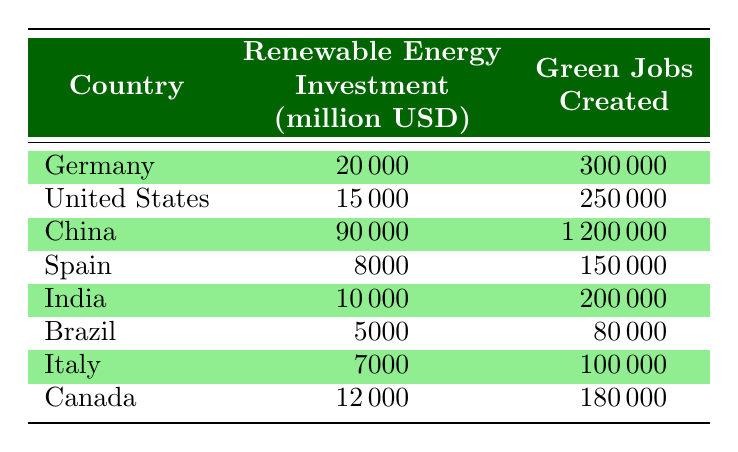What is the renewable energy investment in China? The table lists China’s renewable energy investment, which is specifically provided in the row corresponding to China. It shows a value of 90000 million USD.
Answer: 90000 million USD Which country created the most green jobs? By examining the green jobs created across all countries listed in the table, China has the highest number at 1200000.
Answer: China What is the total renewable energy investment for Germany and Canada combined? To find the total, add Germany's investment of 20000 million USD and Canada's investment of 12000 million USD together: 20000 + 12000 = 32000 million USD.
Answer: 32000 million USD Is it true that Spain created more green jobs than Brazil? Comparing the values from the table, Spain created 150000 green jobs while Brazil created 80000, so Spain indeed created more.
Answer: Yes What is the average number of green jobs created among all countries in the table? First, sum the green jobs created by each country: 300000 + 250000 + 1200000 + 150000 + 200000 + 80000 + 100000 + 180000 = 2100000. There are 8 countries, so divide the total by 8: 2100000 / 8 = 262500.
Answer: 262500 Which country has the lowest renewable energy investment, and what is that amount? The row for Brazil shows it has the lowest renewable energy investment of 5000 million USD.
Answer: Brazil, 5000 million USD How does the renewable energy investment of the United States compare to the investment of Germany? The table shows that the United States has 15000 million USD in renewable energy investment, while Germany has 20000 million USD, which indicates that Germany invested more.
Answer: Germany invested more What is the difference in the number of green jobs created between China and India? China created 1200000 green jobs, and India created 200000. To find the difference, subtract India’s jobs from China’s: 1200000 - 200000 = 1000000.
Answer: 1000000 